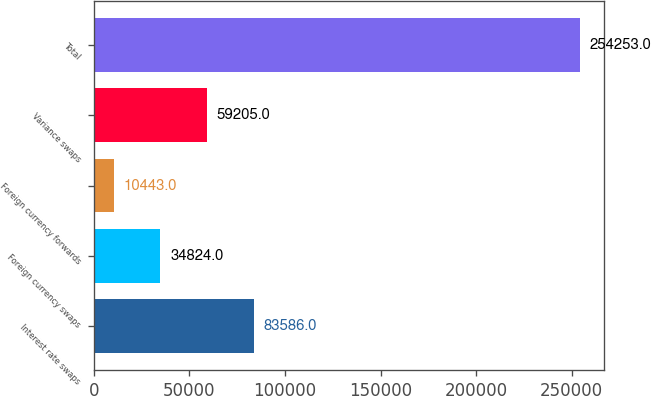<chart> <loc_0><loc_0><loc_500><loc_500><bar_chart><fcel>Interest rate swaps<fcel>Foreign currency swaps<fcel>Foreign currency forwards<fcel>Variance swaps<fcel>Total<nl><fcel>83586<fcel>34824<fcel>10443<fcel>59205<fcel>254253<nl></chart> 